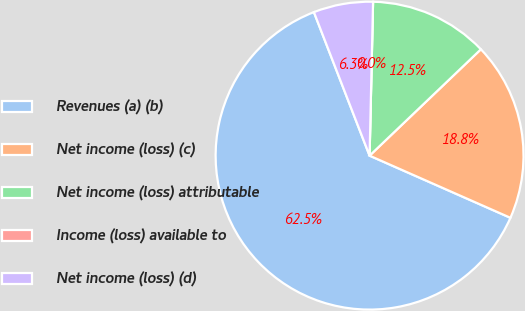<chart> <loc_0><loc_0><loc_500><loc_500><pie_chart><fcel>Revenues (a) (b)<fcel>Net income (loss) (c)<fcel>Net income (loss) attributable<fcel>Income (loss) available to<fcel>Net income (loss) (d)<nl><fcel>62.49%<fcel>18.75%<fcel>12.5%<fcel>0.0%<fcel>6.25%<nl></chart> 